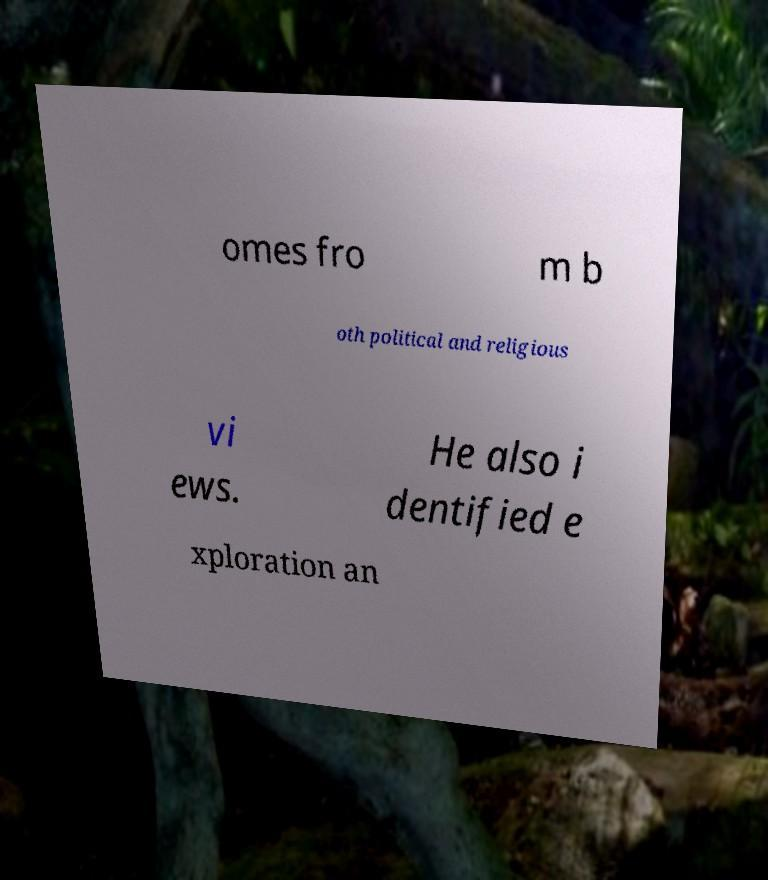Can you accurately transcribe the text from the provided image for me? omes fro m b oth political and religious vi ews. He also i dentified e xploration an 